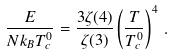Convert formula to latex. <formula><loc_0><loc_0><loc_500><loc_500>\frac { E } { N k _ { B } T _ { c } ^ { 0 } } = \frac { 3 \zeta ( 4 ) } { \zeta ( 3 ) } \left ( \frac { T } { T _ { c } ^ { 0 } } \right ) ^ { 4 } \, .</formula> 